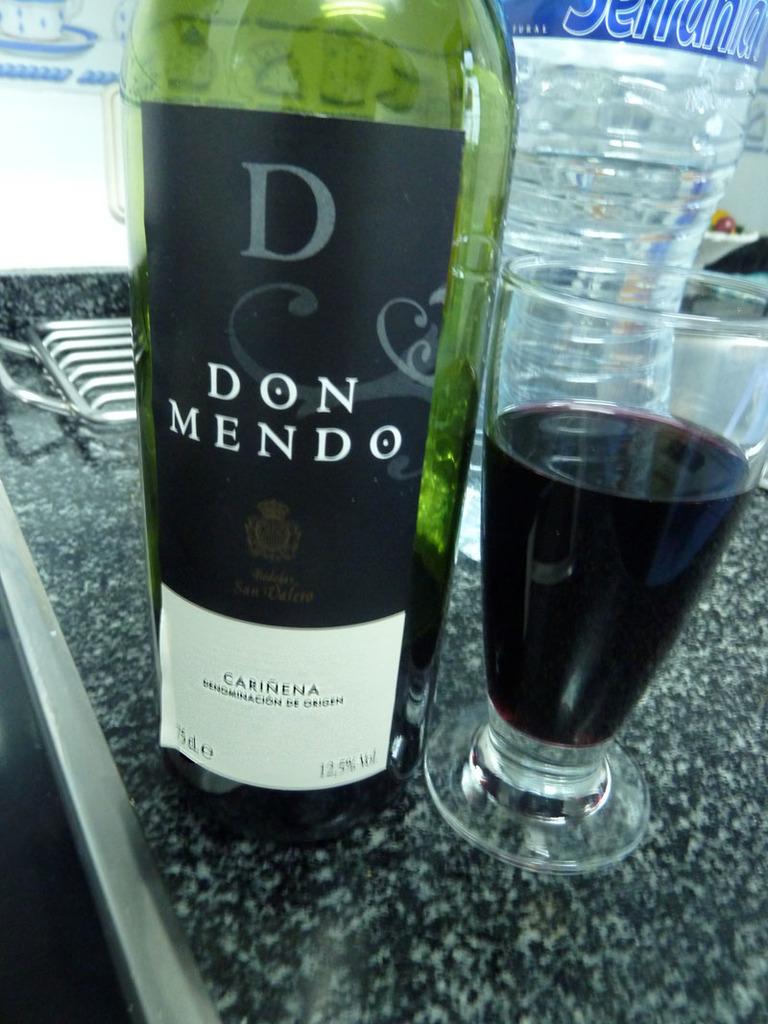What is the wine's alcohol percentage?
Give a very brief answer. 12.5. 